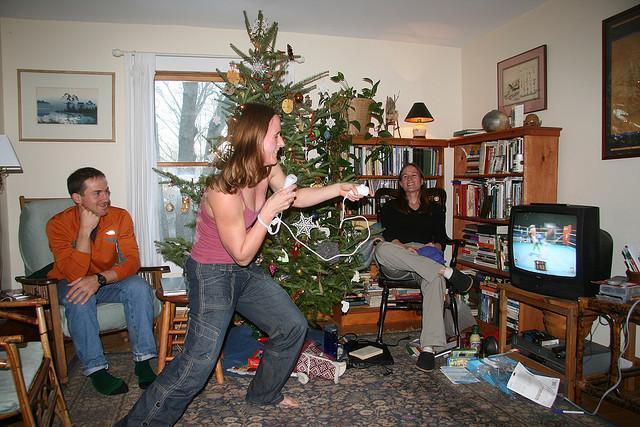What type of television display technology is being used in the living room?
Choose the right answer and clarify with the format: 'Answer: answer
Rationale: rationale.'
Options: Oled, crt, plasma, lcd. Answer: crt.
Rationale: This is an older type of television. 